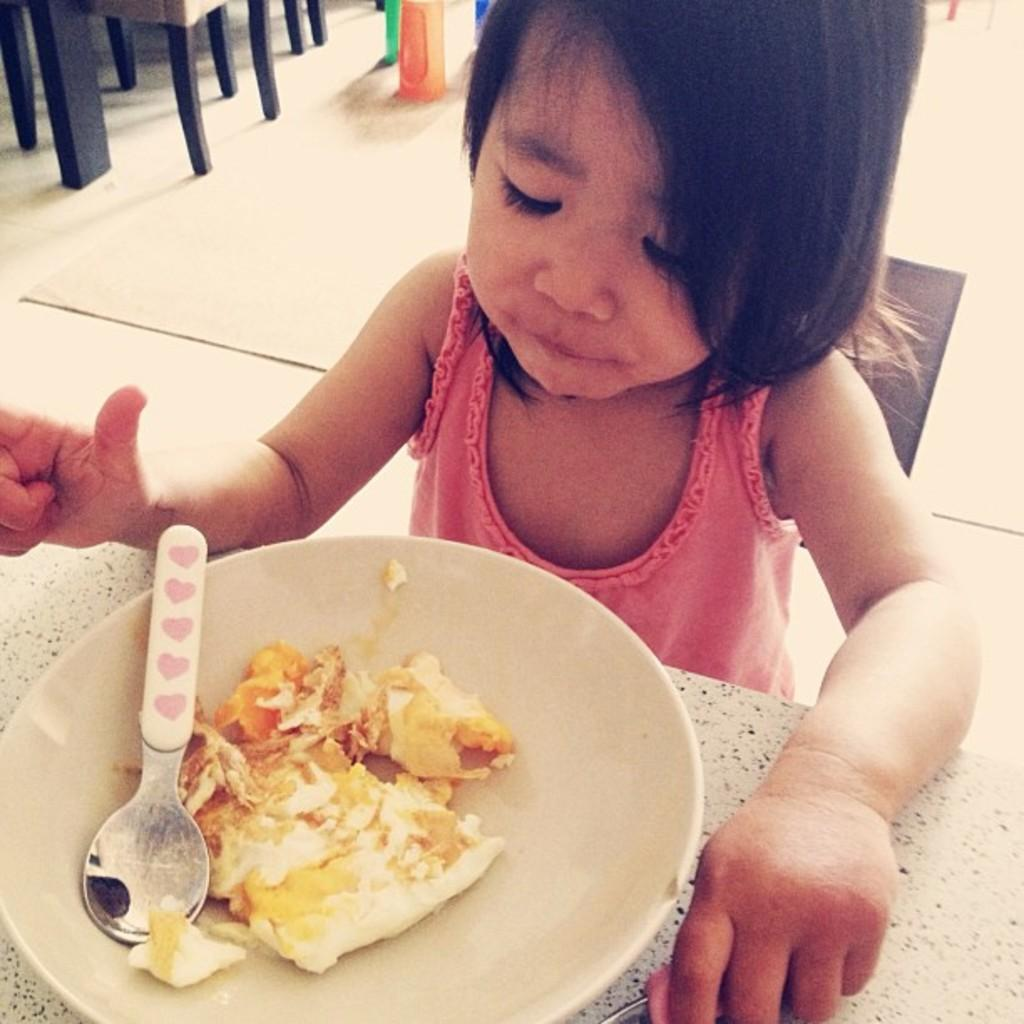What is the main subject of the image? The main subject of the image is a kid. Where is the kid located in relation to other objects in the image? The kid is near a table. What is the kid holding in the image? The kid is holding an object. What can be seen on the table in the image? There is a plate with a food item and a spoon on the table. What is visible in the background of the image? There are objects on the floor in the background. What type of copper ornament can be seen on the kid's head in the image? There is no copper ornament present on the kid's head in the image. How many bites has the kid taken out of the food item on the plate? The image does not show any indication of the kid taking bites out of the food item on the plate. 